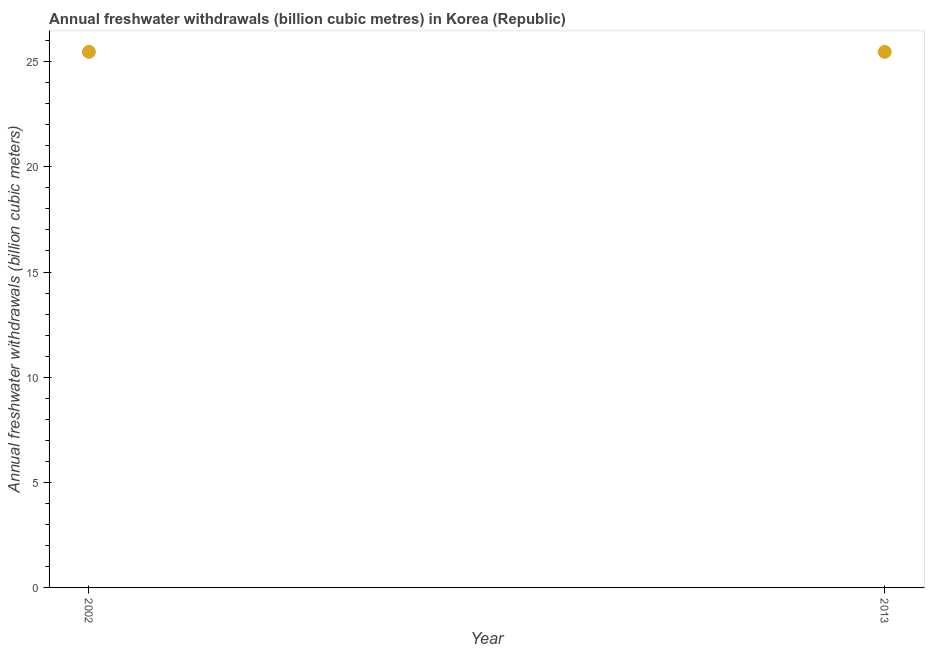What is the annual freshwater withdrawals in 2013?
Provide a succinct answer. 25.47. Across all years, what is the maximum annual freshwater withdrawals?
Keep it short and to the point. 25.47. Across all years, what is the minimum annual freshwater withdrawals?
Offer a very short reply. 25.47. What is the sum of the annual freshwater withdrawals?
Offer a very short reply. 50.94. What is the average annual freshwater withdrawals per year?
Your answer should be compact. 25.47. What is the median annual freshwater withdrawals?
Your answer should be compact. 25.47. What is the ratio of the annual freshwater withdrawals in 2002 to that in 2013?
Keep it short and to the point. 1. Is the annual freshwater withdrawals in 2002 less than that in 2013?
Make the answer very short. No. What is the difference between two consecutive major ticks on the Y-axis?
Offer a very short reply. 5. Are the values on the major ticks of Y-axis written in scientific E-notation?
Your answer should be compact. No. Does the graph contain any zero values?
Offer a very short reply. No. Does the graph contain grids?
Provide a succinct answer. No. What is the title of the graph?
Give a very brief answer. Annual freshwater withdrawals (billion cubic metres) in Korea (Republic). What is the label or title of the Y-axis?
Make the answer very short. Annual freshwater withdrawals (billion cubic meters). What is the Annual freshwater withdrawals (billion cubic meters) in 2002?
Offer a terse response. 25.47. What is the Annual freshwater withdrawals (billion cubic meters) in 2013?
Provide a succinct answer. 25.47. 